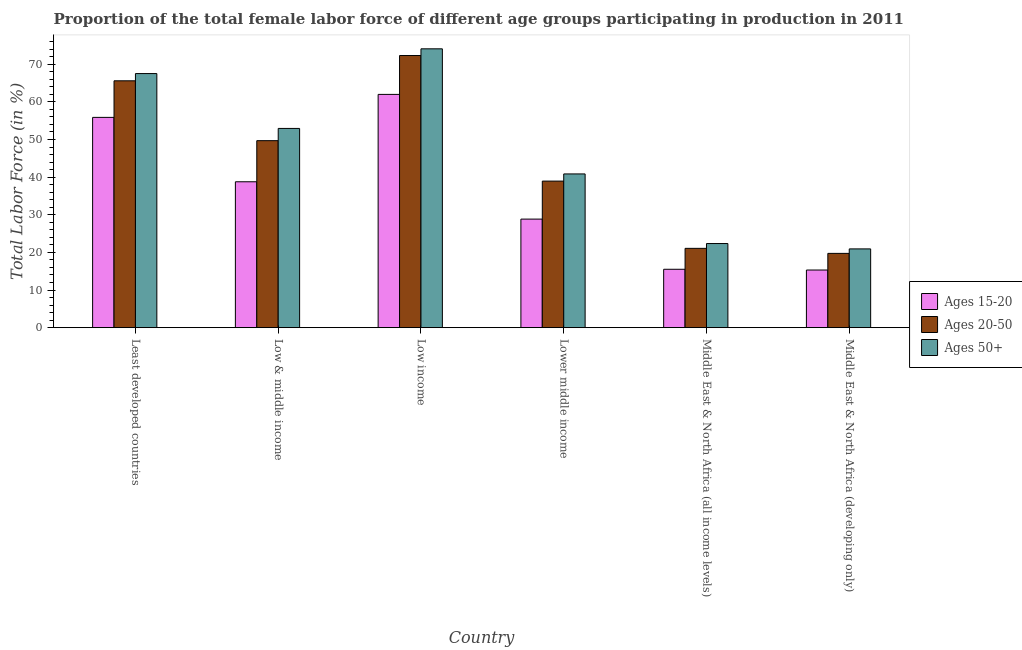How many different coloured bars are there?
Your answer should be compact. 3. How many groups of bars are there?
Provide a succinct answer. 6. Are the number of bars on each tick of the X-axis equal?
Your response must be concise. Yes. How many bars are there on the 6th tick from the left?
Make the answer very short. 3. How many bars are there on the 3rd tick from the right?
Offer a very short reply. 3. What is the label of the 6th group of bars from the left?
Your response must be concise. Middle East & North Africa (developing only). In how many cases, is the number of bars for a given country not equal to the number of legend labels?
Make the answer very short. 0. What is the percentage of female labor force within the age group 15-20 in Middle East & North Africa (all income levels)?
Make the answer very short. 15.51. Across all countries, what is the maximum percentage of female labor force above age 50?
Ensure brevity in your answer.  74.09. Across all countries, what is the minimum percentage of female labor force within the age group 15-20?
Ensure brevity in your answer.  15.31. In which country was the percentage of female labor force within the age group 20-50 minimum?
Offer a very short reply. Middle East & North Africa (developing only). What is the total percentage of female labor force within the age group 15-20 in the graph?
Ensure brevity in your answer.  216.29. What is the difference between the percentage of female labor force above age 50 in Low & middle income and that in Lower middle income?
Give a very brief answer. 12.09. What is the difference between the percentage of female labor force within the age group 20-50 in Lower middle income and the percentage of female labor force within the age group 15-20 in Least developed countries?
Your answer should be compact. -16.93. What is the average percentage of female labor force within the age group 20-50 per country?
Offer a terse response. 44.56. What is the difference between the percentage of female labor force above age 50 and percentage of female labor force within the age group 15-20 in Middle East & North Africa (developing only)?
Provide a succinct answer. 5.62. In how many countries, is the percentage of female labor force within the age group 20-50 greater than 14 %?
Your answer should be compact. 6. What is the ratio of the percentage of female labor force above age 50 in Least developed countries to that in Low income?
Keep it short and to the point. 0.91. Is the percentage of female labor force within the age group 20-50 in Low income less than that in Middle East & North Africa (developing only)?
Provide a short and direct response. No. What is the difference between the highest and the second highest percentage of female labor force within the age group 20-50?
Offer a terse response. 6.71. What is the difference between the highest and the lowest percentage of female labor force above age 50?
Provide a succinct answer. 53.16. Is the sum of the percentage of female labor force within the age group 15-20 in Low income and Middle East & North Africa (all income levels) greater than the maximum percentage of female labor force within the age group 20-50 across all countries?
Offer a very short reply. Yes. What does the 2nd bar from the left in Middle East & North Africa (all income levels) represents?
Make the answer very short. Ages 20-50. What does the 3rd bar from the right in Low & middle income represents?
Ensure brevity in your answer.  Ages 15-20. Is it the case that in every country, the sum of the percentage of female labor force within the age group 15-20 and percentage of female labor force within the age group 20-50 is greater than the percentage of female labor force above age 50?
Your answer should be compact. Yes. How many bars are there?
Your response must be concise. 18. How many countries are there in the graph?
Your response must be concise. 6. Are the values on the major ticks of Y-axis written in scientific E-notation?
Your response must be concise. No. What is the title of the graph?
Give a very brief answer. Proportion of the total female labor force of different age groups participating in production in 2011. Does "Solid fuel" appear as one of the legend labels in the graph?
Your answer should be very brief. No. What is the Total Labor Force (in %) in Ages 15-20 in Least developed countries?
Your answer should be very brief. 55.87. What is the Total Labor Force (in %) in Ages 20-50 in Least developed countries?
Provide a succinct answer. 65.59. What is the Total Labor Force (in %) in Ages 50+ in Least developed countries?
Your answer should be very brief. 67.51. What is the Total Labor Force (in %) in Ages 15-20 in Low & middle income?
Provide a succinct answer. 38.76. What is the Total Labor Force (in %) of Ages 20-50 in Low & middle income?
Your response must be concise. 49.69. What is the Total Labor Force (in %) in Ages 50+ in Low & middle income?
Make the answer very short. 52.94. What is the Total Labor Force (in %) of Ages 15-20 in Low income?
Provide a succinct answer. 61.98. What is the Total Labor Force (in %) of Ages 20-50 in Low income?
Your answer should be very brief. 72.31. What is the Total Labor Force (in %) of Ages 50+ in Low income?
Offer a terse response. 74.09. What is the Total Labor Force (in %) of Ages 15-20 in Lower middle income?
Give a very brief answer. 28.85. What is the Total Labor Force (in %) in Ages 20-50 in Lower middle income?
Offer a very short reply. 38.94. What is the Total Labor Force (in %) of Ages 50+ in Lower middle income?
Provide a succinct answer. 40.85. What is the Total Labor Force (in %) of Ages 15-20 in Middle East & North Africa (all income levels)?
Keep it short and to the point. 15.51. What is the Total Labor Force (in %) of Ages 20-50 in Middle East & North Africa (all income levels)?
Keep it short and to the point. 21.07. What is the Total Labor Force (in %) of Ages 50+ in Middle East & North Africa (all income levels)?
Ensure brevity in your answer.  22.35. What is the Total Labor Force (in %) of Ages 15-20 in Middle East & North Africa (developing only)?
Provide a succinct answer. 15.31. What is the Total Labor Force (in %) of Ages 20-50 in Middle East & North Africa (developing only)?
Give a very brief answer. 19.74. What is the Total Labor Force (in %) in Ages 50+ in Middle East & North Africa (developing only)?
Make the answer very short. 20.93. Across all countries, what is the maximum Total Labor Force (in %) in Ages 15-20?
Provide a succinct answer. 61.98. Across all countries, what is the maximum Total Labor Force (in %) in Ages 20-50?
Offer a terse response. 72.31. Across all countries, what is the maximum Total Labor Force (in %) in Ages 50+?
Make the answer very short. 74.09. Across all countries, what is the minimum Total Labor Force (in %) in Ages 15-20?
Make the answer very short. 15.31. Across all countries, what is the minimum Total Labor Force (in %) in Ages 20-50?
Make the answer very short. 19.74. Across all countries, what is the minimum Total Labor Force (in %) in Ages 50+?
Provide a short and direct response. 20.93. What is the total Total Labor Force (in %) of Ages 15-20 in the graph?
Make the answer very short. 216.29. What is the total Total Labor Force (in %) of Ages 20-50 in the graph?
Keep it short and to the point. 267.34. What is the total Total Labor Force (in %) in Ages 50+ in the graph?
Ensure brevity in your answer.  278.67. What is the difference between the Total Labor Force (in %) of Ages 15-20 in Least developed countries and that in Low & middle income?
Give a very brief answer. 17.11. What is the difference between the Total Labor Force (in %) in Ages 20-50 in Least developed countries and that in Low & middle income?
Provide a succinct answer. 15.91. What is the difference between the Total Labor Force (in %) of Ages 50+ in Least developed countries and that in Low & middle income?
Give a very brief answer. 14.58. What is the difference between the Total Labor Force (in %) in Ages 15-20 in Least developed countries and that in Low income?
Provide a short and direct response. -6.11. What is the difference between the Total Labor Force (in %) in Ages 20-50 in Least developed countries and that in Low income?
Make the answer very short. -6.71. What is the difference between the Total Labor Force (in %) of Ages 50+ in Least developed countries and that in Low income?
Provide a short and direct response. -6.58. What is the difference between the Total Labor Force (in %) in Ages 15-20 in Least developed countries and that in Lower middle income?
Provide a short and direct response. 27.03. What is the difference between the Total Labor Force (in %) of Ages 20-50 in Least developed countries and that in Lower middle income?
Keep it short and to the point. 26.65. What is the difference between the Total Labor Force (in %) in Ages 50+ in Least developed countries and that in Lower middle income?
Offer a terse response. 26.67. What is the difference between the Total Labor Force (in %) of Ages 15-20 in Least developed countries and that in Middle East & North Africa (all income levels)?
Offer a very short reply. 40.36. What is the difference between the Total Labor Force (in %) of Ages 20-50 in Least developed countries and that in Middle East & North Africa (all income levels)?
Your response must be concise. 44.52. What is the difference between the Total Labor Force (in %) in Ages 50+ in Least developed countries and that in Middle East & North Africa (all income levels)?
Keep it short and to the point. 45.16. What is the difference between the Total Labor Force (in %) of Ages 15-20 in Least developed countries and that in Middle East & North Africa (developing only)?
Ensure brevity in your answer.  40.56. What is the difference between the Total Labor Force (in %) of Ages 20-50 in Least developed countries and that in Middle East & North Africa (developing only)?
Your response must be concise. 45.85. What is the difference between the Total Labor Force (in %) of Ages 50+ in Least developed countries and that in Middle East & North Africa (developing only)?
Ensure brevity in your answer.  46.58. What is the difference between the Total Labor Force (in %) in Ages 15-20 in Low & middle income and that in Low income?
Provide a short and direct response. -23.22. What is the difference between the Total Labor Force (in %) of Ages 20-50 in Low & middle income and that in Low income?
Provide a succinct answer. -22.62. What is the difference between the Total Labor Force (in %) of Ages 50+ in Low & middle income and that in Low income?
Offer a terse response. -21.16. What is the difference between the Total Labor Force (in %) of Ages 15-20 in Low & middle income and that in Lower middle income?
Ensure brevity in your answer.  9.92. What is the difference between the Total Labor Force (in %) in Ages 20-50 in Low & middle income and that in Lower middle income?
Your answer should be compact. 10.74. What is the difference between the Total Labor Force (in %) in Ages 50+ in Low & middle income and that in Lower middle income?
Give a very brief answer. 12.09. What is the difference between the Total Labor Force (in %) of Ages 15-20 in Low & middle income and that in Middle East & North Africa (all income levels)?
Make the answer very short. 23.25. What is the difference between the Total Labor Force (in %) of Ages 20-50 in Low & middle income and that in Middle East & North Africa (all income levels)?
Provide a succinct answer. 28.61. What is the difference between the Total Labor Force (in %) of Ages 50+ in Low & middle income and that in Middle East & North Africa (all income levels)?
Give a very brief answer. 30.58. What is the difference between the Total Labor Force (in %) of Ages 15-20 in Low & middle income and that in Middle East & North Africa (developing only)?
Your answer should be compact. 23.45. What is the difference between the Total Labor Force (in %) of Ages 20-50 in Low & middle income and that in Middle East & North Africa (developing only)?
Provide a short and direct response. 29.95. What is the difference between the Total Labor Force (in %) in Ages 50+ in Low & middle income and that in Middle East & North Africa (developing only)?
Provide a succinct answer. 32.01. What is the difference between the Total Labor Force (in %) in Ages 15-20 in Low income and that in Lower middle income?
Ensure brevity in your answer.  33.13. What is the difference between the Total Labor Force (in %) in Ages 20-50 in Low income and that in Lower middle income?
Your response must be concise. 33.37. What is the difference between the Total Labor Force (in %) of Ages 50+ in Low income and that in Lower middle income?
Give a very brief answer. 33.24. What is the difference between the Total Labor Force (in %) in Ages 15-20 in Low income and that in Middle East & North Africa (all income levels)?
Provide a short and direct response. 46.47. What is the difference between the Total Labor Force (in %) of Ages 20-50 in Low income and that in Middle East & North Africa (all income levels)?
Provide a short and direct response. 51.24. What is the difference between the Total Labor Force (in %) in Ages 50+ in Low income and that in Middle East & North Africa (all income levels)?
Give a very brief answer. 51.74. What is the difference between the Total Labor Force (in %) in Ages 15-20 in Low income and that in Middle East & North Africa (developing only)?
Make the answer very short. 46.66. What is the difference between the Total Labor Force (in %) in Ages 20-50 in Low income and that in Middle East & North Africa (developing only)?
Your answer should be very brief. 52.57. What is the difference between the Total Labor Force (in %) of Ages 50+ in Low income and that in Middle East & North Africa (developing only)?
Offer a very short reply. 53.16. What is the difference between the Total Labor Force (in %) in Ages 15-20 in Lower middle income and that in Middle East & North Africa (all income levels)?
Offer a terse response. 13.33. What is the difference between the Total Labor Force (in %) in Ages 20-50 in Lower middle income and that in Middle East & North Africa (all income levels)?
Make the answer very short. 17.87. What is the difference between the Total Labor Force (in %) of Ages 50+ in Lower middle income and that in Middle East & North Africa (all income levels)?
Your response must be concise. 18.49. What is the difference between the Total Labor Force (in %) in Ages 15-20 in Lower middle income and that in Middle East & North Africa (developing only)?
Give a very brief answer. 13.53. What is the difference between the Total Labor Force (in %) of Ages 20-50 in Lower middle income and that in Middle East & North Africa (developing only)?
Give a very brief answer. 19.2. What is the difference between the Total Labor Force (in %) in Ages 50+ in Lower middle income and that in Middle East & North Africa (developing only)?
Provide a succinct answer. 19.92. What is the difference between the Total Labor Force (in %) of Ages 15-20 in Middle East & North Africa (all income levels) and that in Middle East & North Africa (developing only)?
Ensure brevity in your answer.  0.2. What is the difference between the Total Labor Force (in %) of Ages 20-50 in Middle East & North Africa (all income levels) and that in Middle East & North Africa (developing only)?
Keep it short and to the point. 1.33. What is the difference between the Total Labor Force (in %) of Ages 50+ in Middle East & North Africa (all income levels) and that in Middle East & North Africa (developing only)?
Ensure brevity in your answer.  1.42. What is the difference between the Total Labor Force (in %) in Ages 15-20 in Least developed countries and the Total Labor Force (in %) in Ages 20-50 in Low & middle income?
Keep it short and to the point. 6.19. What is the difference between the Total Labor Force (in %) of Ages 15-20 in Least developed countries and the Total Labor Force (in %) of Ages 50+ in Low & middle income?
Ensure brevity in your answer.  2.94. What is the difference between the Total Labor Force (in %) in Ages 20-50 in Least developed countries and the Total Labor Force (in %) in Ages 50+ in Low & middle income?
Make the answer very short. 12.66. What is the difference between the Total Labor Force (in %) in Ages 15-20 in Least developed countries and the Total Labor Force (in %) in Ages 20-50 in Low income?
Keep it short and to the point. -16.44. What is the difference between the Total Labor Force (in %) in Ages 15-20 in Least developed countries and the Total Labor Force (in %) in Ages 50+ in Low income?
Make the answer very short. -18.22. What is the difference between the Total Labor Force (in %) in Ages 20-50 in Least developed countries and the Total Labor Force (in %) in Ages 50+ in Low income?
Make the answer very short. -8.5. What is the difference between the Total Labor Force (in %) in Ages 15-20 in Least developed countries and the Total Labor Force (in %) in Ages 20-50 in Lower middle income?
Your answer should be compact. 16.93. What is the difference between the Total Labor Force (in %) of Ages 15-20 in Least developed countries and the Total Labor Force (in %) of Ages 50+ in Lower middle income?
Your answer should be very brief. 15.03. What is the difference between the Total Labor Force (in %) in Ages 20-50 in Least developed countries and the Total Labor Force (in %) in Ages 50+ in Lower middle income?
Keep it short and to the point. 24.75. What is the difference between the Total Labor Force (in %) of Ages 15-20 in Least developed countries and the Total Labor Force (in %) of Ages 20-50 in Middle East & North Africa (all income levels)?
Give a very brief answer. 34.8. What is the difference between the Total Labor Force (in %) of Ages 15-20 in Least developed countries and the Total Labor Force (in %) of Ages 50+ in Middle East & North Africa (all income levels)?
Ensure brevity in your answer.  33.52. What is the difference between the Total Labor Force (in %) of Ages 20-50 in Least developed countries and the Total Labor Force (in %) of Ages 50+ in Middle East & North Africa (all income levels)?
Your response must be concise. 43.24. What is the difference between the Total Labor Force (in %) of Ages 15-20 in Least developed countries and the Total Labor Force (in %) of Ages 20-50 in Middle East & North Africa (developing only)?
Make the answer very short. 36.13. What is the difference between the Total Labor Force (in %) in Ages 15-20 in Least developed countries and the Total Labor Force (in %) in Ages 50+ in Middle East & North Africa (developing only)?
Provide a succinct answer. 34.94. What is the difference between the Total Labor Force (in %) of Ages 20-50 in Least developed countries and the Total Labor Force (in %) of Ages 50+ in Middle East & North Africa (developing only)?
Your answer should be compact. 44.66. What is the difference between the Total Labor Force (in %) in Ages 15-20 in Low & middle income and the Total Labor Force (in %) in Ages 20-50 in Low income?
Your answer should be compact. -33.54. What is the difference between the Total Labor Force (in %) of Ages 15-20 in Low & middle income and the Total Labor Force (in %) of Ages 50+ in Low income?
Your answer should be compact. -35.33. What is the difference between the Total Labor Force (in %) in Ages 20-50 in Low & middle income and the Total Labor Force (in %) in Ages 50+ in Low income?
Give a very brief answer. -24.41. What is the difference between the Total Labor Force (in %) in Ages 15-20 in Low & middle income and the Total Labor Force (in %) in Ages 20-50 in Lower middle income?
Make the answer very short. -0.18. What is the difference between the Total Labor Force (in %) in Ages 15-20 in Low & middle income and the Total Labor Force (in %) in Ages 50+ in Lower middle income?
Keep it short and to the point. -2.08. What is the difference between the Total Labor Force (in %) in Ages 20-50 in Low & middle income and the Total Labor Force (in %) in Ages 50+ in Lower middle income?
Give a very brief answer. 8.84. What is the difference between the Total Labor Force (in %) of Ages 15-20 in Low & middle income and the Total Labor Force (in %) of Ages 20-50 in Middle East & North Africa (all income levels)?
Give a very brief answer. 17.69. What is the difference between the Total Labor Force (in %) in Ages 15-20 in Low & middle income and the Total Labor Force (in %) in Ages 50+ in Middle East & North Africa (all income levels)?
Provide a succinct answer. 16.41. What is the difference between the Total Labor Force (in %) of Ages 20-50 in Low & middle income and the Total Labor Force (in %) of Ages 50+ in Middle East & North Africa (all income levels)?
Your answer should be very brief. 27.33. What is the difference between the Total Labor Force (in %) of Ages 15-20 in Low & middle income and the Total Labor Force (in %) of Ages 20-50 in Middle East & North Africa (developing only)?
Your answer should be compact. 19.02. What is the difference between the Total Labor Force (in %) of Ages 15-20 in Low & middle income and the Total Labor Force (in %) of Ages 50+ in Middle East & North Africa (developing only)?
Your answer should be very brief. 17.83. What is the difference between the Total Labor Force (in %) of Ages 20-50 in Low & middle income and the Total Labor Force (in %) of Ages 50+ in Middle East & North Africa (developing only)?
Offer a terse response. 28.76. What is the difference between the Total Labor Force (in %) in Ages 15-20 in Low income and the Total Labor Force (in %) in Ages 20-50 in Lower middle income?
Offer a very short reply. 23.04. What is the difference between the Total Labor Force (in %) of Ages 15-20 in Low income and the Total Labor Force (in %) of Ages 50+ in Lower middle income?
Your answer should be very brief. 21.13. What is the difference between the Total Labor Force (in %) in Ages 20-50 in Low income and the Total Labor Force (in %) in Ages 50+ in Lower middle income?
Keep it short and to the point. 31.46. What is the difference between the Total Labor Force (in %) in Ages 15-20 in Low income and the Total Labor Force (in %) in Ages 20-50 in Middle East & North Africa (all income levels)?
Ensure brevity in your answer.  40.91. What is the difference between the Total Labor Force (in %) in Ages 15-20 in Low income and the Total Labor Force (in %) in Ages 50+ in Middle East & North Africa (all income levels)?
Provide a short and direct response. 39.63. What is the difference between the Total Labor Force (in %) of Ages 20-50 in Low income and the Total Labor Force (in %) of Ages 50+ in Middle East & North Africa (all income levels)?
Provide a short and direct response. 49.95. What is the difference between the Total Labor Force (in %) in Ages 15-20 in Low income and the Total Labor Force (in %) in Ages 20-50 in Middle East & North Africa (developing only)?
Ensure brevity in your answer.  42.24. What is the difference between the Total Labor Force (in %) of Ages 15-20 in Low income and the Total Labor Force (in %) of Ages 50+ in Middle East & North Africa (developing only)?
Keep it short and to the point. 41.05. What is the difference between the Total Labor Force (in %) of Ages 20-50 in Low income and the Total Labor Force (in %) of Ages 50+ in Middle East & North Africa (developing only)?
Offer a terse response. 51.38. What is the difference between the Total Labor Force (in %) in Ages 15-20 in Lower middle income and the Total Labor Force (in %) in Ages 20-50 in Middle East & North Africa (all income levels)?
Your answer should be very brief. 7.77. What is the difference between the Total Labor Force (in %) in Ages 15-20 in Lower middle income and the Total Labor Force (in %) in Ages 50+ in Middle East & North Africa (all income levels)?
Provide a succinct answer. 6.49. What is the difference between the Total Labor Force (in %) in Ages 20-50 in Lower middle income and the Total Labor Force (in %) in Ages 50+ in Middle East & North Africa (all income levels)?
Your answer should be compact. 16.59. What is the difference between the Total Labor Force (in %) of Ages 15-20 in Lower middle income and the Total Labor Force (in %) of Ages 20-50 in Middle East & North Africa (developing only)?
Make the answer very short. 9.11. What is the difference between the Total Labor Force (in %) in Ages 15-20 in Lower middle income and the Total Labor Force (in %) in Ages 50+ in Middle East & North Africa (developing only)?
Give a very brief answer. 7.92. What is the difference between the Total Labor Force (in %) of Ages 20-50 in Lower middle income and the Total Labor Force (in %) of Ages 50+ in Middle East & North Africa (developing only)?
Offer a terse response. 18.01. What is the difference between the Total Labor Force (in %) in Ages 15-20 in Middle East & North Africa (all income levels) and the Total Labor Force (in %) in Ages 20-50 in Middle East & North Africa (developing only)?
Offer a terse response. -4.23. What is the difference between the Total Labor Force (in %) in Ages 15-20 in Middle East & North Africa (all income levels) and the Total Labor Force (in %) in Ages 50+ in Middle East & North Africa (developing only)?
Offer a very short reply. -5.42. What is the difference between the Total Labor Force (in %) in Ages 20-50 in Middle East & North Africa (all income levels) and the Total Labor Force (in %) in Ages 50+ in Middle East & North Africa (developing only)?
Give a very brief answer. 0.14. What is the average Total Labor Force (in %) of Ages 15-20 per country?
Your answer should be very brief. 36.05. What is the average Total Labor Force (in %) in Ages 20-50 per country?
Make the answer very short. 44.56. What is the average Total Labor Force (in %) in Ages 50+ per country?
Your answer should be very brief. 46.45. What is the difference between the Total Labor Force (in %) in Ages 15-20 and Total Labor Force (in %) in Ages 20-50 in Least developed countries?
Offer a very short reply. -9.72. What is the difference between the Total Labor Force (in %) in Ages 15-20 and Total Labor Force (in %) in Ages 50+ in Least developed countries?
Offer a terse response. -11.64. What is the difference between the Total Labor Force (in %) in Ages 20-50 and Total Labor Force (in %) in Ages 50+ in Least developed countries?
Provide a succinct answer. -1.92. What is the difference between the Total Labor Force (in %) of Ages 15-20 and Total Labor Force (in %) of Ages 20-50 in Low & middle income?
Offer a terse response. -10.92. What is the difference between the Total Labor Force (in %) of Ages 15-20 and Total Labor Force (in %) of Ages 50+ in Low & middle income?
Keep it short and to the point. -14.17. What is the difference between the Total Labor Force (in %) of Ages 20-50 and Total Labor Force (in %) of Ages 50+ in Low & middle income?
Offer a very short reply. -3.25. What is the difference between the Total Labor Force (in %) of Ages 15-20 and Total Labor Force (in %) of Ages 20-50 in Low income?
Give a very brief answer. -10.33. What is the difference between the Total Labor Force (in %) of Ages 15-20 and Total Labor Force (in %) of Ages 50+ in Low income?
Provide a succinct answer. -12.11. What is the difference between the Total Labor Force (in %) in Ages 20-50 and Total Labor Force (in %) in Ages 50+ in Low income?
Offer a terse response. -1.78. What is the difference between the Total Labor Force (in %) in Ages 15-20 and Total Labor Force (in %) in Ages 20-50 in Lower middle income?
Ensure brevity in your answer.  -10.1. What is the difference between the Total Labor Force (in %) of Ages 15-20 and Total Labor Force (in %) of Ages 50+ in Lower middle income?
Offer a very short reply. -12. What is the difference between the Total Labor Force (in %) of Ages 20-50 and Total Labor Force (in %) of Ages 50+ in Lower middle income?
Provide a short and direct response. -1.91. What is the difference between the Total Labor Force (in %) of Ages 15-20 and Total Labor Force (in %) of Ages 20-50 in Middle East & North Africa (all income levels)?
Your response must be concise. -5.56. What is the difference between the Total Labor Force (in %) in Ages 15-20 and Total Labor Force (in %) in Ages 50+ in Middle East & North Africa (all income levels)?
Provide a short and direct response. -6.84. What is the difference between the Total Labor Force (in %) of Ages 20-50 and Total Labor Force (in %) of Ages 50+ in Middle East & North Africa (all income levels)?
Keep it short and to the point. -1.28. What is the difference between the Total Labor Force (in %) in Ages 15-20 and Total Labor Force (in %) in Ages 20-50 in Middle East & North Africa (developing only)?
Provide a short and direct response. -4.42. What is the difference between the Total Labor Force (in %) in Ages 15-20 and Total Labor Force (in %) in Ages 50+ in Middle East & North Africa (developing only)?
Keep it short and to the point. -5.62. What is the difference between the Total Labor Force (in %) of Ages 20-50 and Total Labor Force (in %) of Ages 50+ in Middle East & North Africa (developing only)?
Offer a very short reply. -1.19. What is the ratio of the Total Labor Force (in %) of Ages 15-20 in Least developed countries to that in Low & middle income?
Offer a very short reply. 1.44. What is the ratio of the Total Labor Force (in %) in Ages 20-50 in Least developed countries to that in Low & middle income?
Provide a succinct answer. 1.32. What is the ratio of the Total Labor Force (in %) of Ages 50+ in Least developed countries to that in Low & middle income?
Offer a terse response. 1.28. What is the ratio of the Total Labor Force (in %) in Ages 15-20 in Least developed countries to that in Low income?
Your answer should be compact. 0.9. What is the ratio of the Total Labor Force (in %) of Ages 20-50 in Least developed countries to that in Low income?
Offer a very short reply. 0.91. What is the ratio of the Total Labor Force (in %) in Ages 50+ in Least developed countries to that in Low income?
Your answer should be compact. 0.91. What is the ratio of the Total Labor Force (in %) in Ages 15-20 in Least developed countries to that in Lower middle income?
Your response must be concise. 1.94. What is the ratio of the Total Labor Force (in %) in Ages 20-50 in Least developed countries to that in Lower middle income?
Your answer should be compact. 1.68. What is the ratio of the Total Labor Force (in %) in Ages 50+ in Least developed countries to that in Lower middle income?
Offer a terse response. 1.65. What is the ratio of the Total Labor Force (in %) of Ages 15-20 in Least developed countries to that in Middle East & North Africa (all income levels)?
Make the answer very short. 3.6. What is the ratio of the Total Labor Force (in %) in Ages 20-50 in Least developed countries to that in Middle East & North Africa (all income levels)?
Make the answer very short. 3.11. What is the ratio of the Total Labor Force (in %) of Ages 50+ in Least developed countries to that in Middle East & North Africa (all income levels)?
Offer a terse response. 3.02. What is the ratio of the Total Labor Force (in %) in Ages 15-20 in Least developed countries to that in Middle East & North Africa (developing only)?
Ensure brevity in your answer.  3.65. What is the ratio of the Total Labor Force (in %) in Ages 20-50 in Least developed countries to that in Middle East & North Africa (developing only)?
Your response must be concise. 3.32. What is the ratio of the Total Labor Force (in %) of Ages 50+ in Least developed countries to that in Middle East & North Africa (developing only)?
Offer a very short reply. 3.23. What is the ratio of the Total Labor Force (in %) in Ages 15-20 in Low & middle income to that in Low income?
Your answer should be very brief. 0.63. What is the ratio of the Total Labor Force (in %) of Ages 20-50 in Low & middle income to that in Low income?
Provide a succinct answer. 0.69. What is the ratio of the Total Labor Force (in %) in Ages 50+ in Low & middle income to that in Low income?
Keep it short and to the point. 0.71. What is the ratio of the Total Labor Force (in %) of Ages 15-20 in Low & middle income to that in Lower middle income?
Keep it short and to the point. 1.34. What is the ratio of the Total Labor Force (in %) of Ages 20-50 in Low & middle income to that in Lower middle income?
Ensure brevity in your answer.  1.28. What is the ratio of the Total Labor Force (in %) in Ages 50+ in Low & middle income to that in Lower middle income?
Make the answer very short. 1.3. What is the ratio of the Total Labor Force (in %) of Ages 15-20 in Low & middle income to that in Middle East & North Africa (all income levels)?
Provide a short and direct response. 2.5. What is the ratio of the Total Labor Force (in %) of Ages 20-50 in Low & middle income to that in Middle East & North Africa (all income levels)?
Give a very brief answer. 2.36. What is the ratio of the Total Labor Force (in %) of Ages 50+ in Low & middle income to that in Middle East & North Africa (all income levels)?
Make the answer very short. 2.37. What is the ratio of the Total Labor Force (in %) in Ages 15-20 in Low & middle income to that in Middle East & North Africa (developing only)?
Offer a very short reply. 2.53. What is the ratio of the Total Labor Force (in %) in Ages 20-50 in Low & middle income to that in Middle East & North Africa (developing only)?
Your response must be concise. 2.52. What is the ratio of the Total Labor Force (in %) in Ages 50+ in Low & middle income to that in Middle East & North Africa (developing only)?
Keep it short and to the point. 2.53. What is the ratio of the Total Labor Force (in %) of Ages 15-20 in Low income to that in Lower middle income?
Offer a terse response. 2.15. What is the ratio of the Total Labor Force (in %) of Ages 20-50 in Low income to that in Lower middle income?
Provide a succinct answer. 1.86. What is the ratio of the Total Labor Force (in %) in Ages 50+ in Low income to that in Lower middle income?
Offer a very short reply. 1.81. What is the ratio of the Total Labor Force (in %) in Ages 15-20 in Low income to that in Middle East & North Africa (all income levels)?
Your answer should be very brief. 4. What is the ratio of the Total Labor Force (in %) in Ages 20-50 in Low income to that in Middle East & North Africa (all income levels)?
Give a very brief answer. 3.43. What is the ratio of the Total Labor Force (in %) of Ages 50+ in Low income to that in Middle East & North Africa (all income levels)?
Your response must be concise. 3.31. What is the ratio of the Total Labor Force (in %) of Ages 15-20 in Low income to that in Middle East & North Africa (developing only)?
Provide a succinct answer. 4.05. What is the ratio of the Total Labor Force (in %) in Ages 20-50 in Low income to that in Middle East & North Africa (developing only)?
Keep it short and to the point. 3.66. What is the ratio of the Total Labor Force (in %) of Ages 50+ in Low income to that in Middle East & North Africa (developing only)?
Ensure brevity in your answer.  3.54. What is the ratio of the Total Labor Force (in %) of Ages 15-20 in Lower middle income to that in Middle East & North Africa (all income levels)?
Ensure brevity in your answer.  1.86. What is the ratio of the Total Labor Force (in %) in Ages 20-50 in Lower middle income to that in Middle East & North Africa (all income levels)?
Provide a succinct answer. 1.85. What is the ratio of the Total Labor Force (in %) in Ages 50+ in Lower middle income to that in Middle East & North Africa (all income levels)?
Give a very brief answer. 1.83. What is the ratio of the Total Labor Force (in %) of Ages 15-20 in Lower middle income to that in Middle East & North Africa (developing only)?
Your answer should be very brief. 1.88. What is the ratio of the Total Labor Force (in %) of Ages 20-50 in Lower middle income to that in Middle East & North Africa (developing only)?
Offer a terse response. 1.97. What is the ratio of the Total Labor Force (in %) in Ages 50+ in Lower middle income to that in Middle East & North Africa (developing only)?
Your answer should be compact. 1.95. What is the ratio of the Total Labor Force (in %) of Ages 15-20 in Middle East & North Africa (all income levels) to that in Middle East & North Africa (developing only)?
Ensure brevity in your answer.  1.01. What is the ratio of the Total Labor Force (in %) in Ages 20-50 in Middle East & North Africa (all income levels) to that in Middle East & North Africa (developing only)?
Ensure brevity in your answer.  1.07. What is the ratio of the Total Labor Force (in %) in Ages 50+ in Middle East & North Africa (all income levels) to that in Middle East & North Africa (developing only)?
Ensure brevity in your answer.  1.07. What is the difference between the highest and the second highest Total Labor Force (in %) of Ages 15-20?
Your answer should be compact. 6.11. What is the difference between the highest and the second highest Total Labor Force (in %) of Ages 20-50?
Provide a succinct answer. 6.71. What is the difference between the highest and the second highest Total Labor Force (in %) of Ages 50+?
Offer a terse response. 6.58. What is the difference between the highest and the lowest Total Labor Force (in %) of Ages 15-20?
Keep it short and to the point. 46.66. What is the difference between the highest and the lowest Total Labor Force (in %) in Ages 20-50?
Your response must be concise. 52.57. What is the difference between the highest and the lowest Total Labor Force (in %) in Ages 50+?
Ensure brevity in your answer.  53.16. 